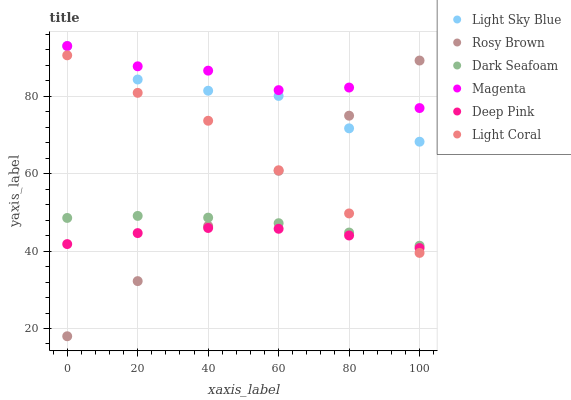Does Deep Pink have the minimum area under the curve?
Answer yes or no. Yes. Does Magenta have the maximum area under the curve?
Answer yes or no. Yes. Does Rosy Brown have the minimum area under the curve?
Answer yes or no. No. Does Rosy Brown have the maximum area under the curve?
Answer yes or no. No. Is Rosy Brown the smoothest?
Answer yes or no. Yes. Is Magenta the roughest?
Answer yes or no. Yes. Is Light Coral the smoothest?
Answer yes or no. No. Is Light Coral the roughest?
Answer yes or no. No. Does Rosy Brown have the lowest value?
Answer yes or no. Yes. Does Light Coral have the lowest value?
Answer yes or no. No. Does Magenta have the highest value?
Answer yes or no. Yes. Does Rosy Brown have the highest value?
Answer yes or no. No. Is Dark Seafoam less than Light Sky Blue?
Answer yes or no. Yes. Is Magenta greater than Light Coral?
Answer yes or no. Yes. Does Rosy Brown intersect Deep Pink?
Answer yes or no. Yes. Is Rosy Brown less than Deep Pink?
Answer yes or no. No. Is Rosy Brown greater than Deep Pink?
Answer yes or no. No. Does Dark Seafoam intersect Light Sky Blue?
Answer yes or no. No. 